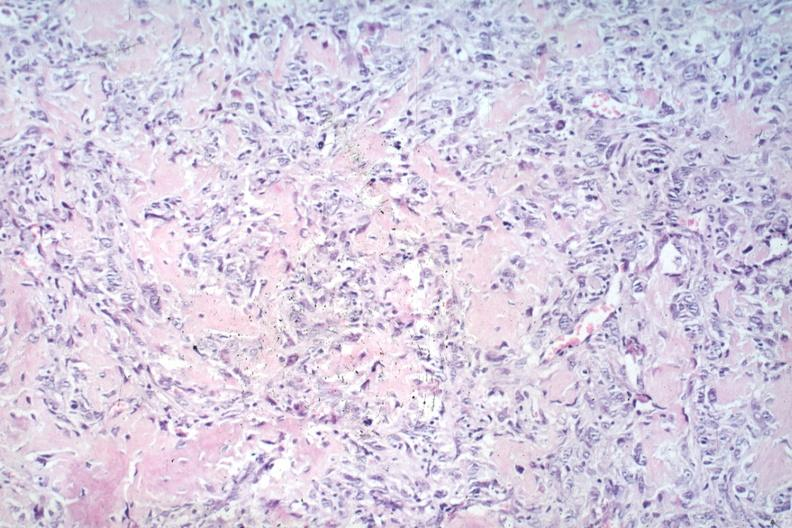what does this image show?
Answer the question using a single word or phrase. Anaplastic tumor cells and osteoid 